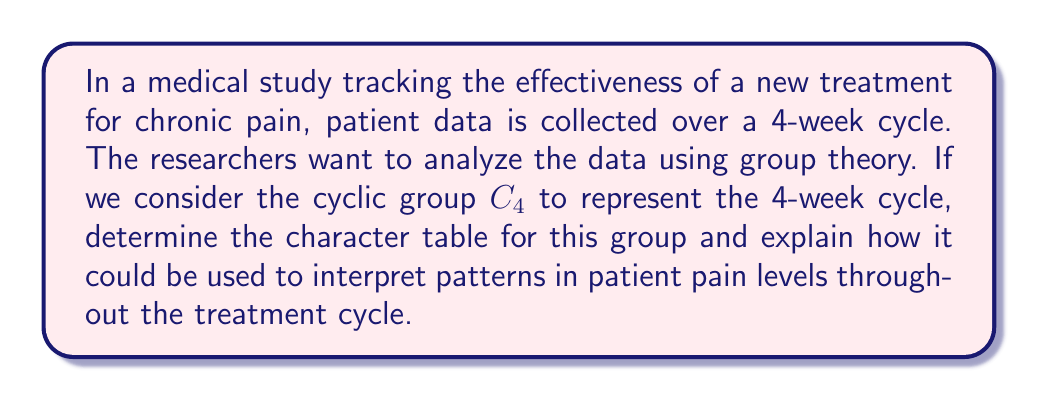Can you answer this question? To determine the character table for the cyclic group $C_4$, we'll follow these steps:

1) First, recall that $C_4$ has 4 elements: $\{e, g, g^2, g^3\}$, where $e$ is the identity and $g$ is the generator of the group.

2) $C_4$ has 4 irreducible representations, all of dimension 1, because it's an abelian group.

3) The characters of these representations are given by:

   $\chi_j(g^k) = (\omega^j)^k$, where $\omega = e^{2\pi i/4} = i$, and $j, k = 0, 1, 2, 3$

4) Let's calculate each character:

   For $\chi_0$: $\chi_0(g^k) = 1^k = 1$ for all $k$
   For $\chi_1$: $\chi_1(g^k) = i^k$
   For $\chi_2$: $\chi_2(g^k) = (i^2)^k = (-1)^k$
   For $\chi_3$: $\chi_3(g^k) = (i^3)^k = (-i)^k$

5) Now we can construct the character table:

   $$
   \begin{array}{c|cccc}
    C_4 & e & g & g^2 & g^3 \\
   \hline
   \chi_0 & 1 & 1 & 1 & 1 \\
   \chi_1 & 1 & i & -1 & -i \\
   \chi_2 & 1 & -1 & 1 & -1 \\
   \chi_3 & 1 & -i & -1 & i
   \end{array}
   $$

6) Interpretation for pain level analysis:
   - $\chi_0$ represents constant pain levels (no change over the cycle)
   - $\chi_1$ represents a gradual increase and then decrease in pain
   - $\chi_2$ represents alternating high and low pain levels
   - $\chi_3$ represents a gradual decrease and then increase in pain

By decomposing patient data into these characters, researchers can identify dominant patterns in pain levels throughout the treatment cycle, potentially leading to more personalized treatment plans for chronic pain patients.
Answer: $$
\begin{array}{c|cccc}
C_4 & e & g & g^2 & g^3 \\
\hline
\chi_0 & 1 & 1 & 1 & 1 \\
\chi_1 & 1 & i & -1 & -i \\
\chi_2 & 1 & -1 & 1 & -1 \\
\chi_3 & 1 & -i & -1 & i
\end{array}
$$ 